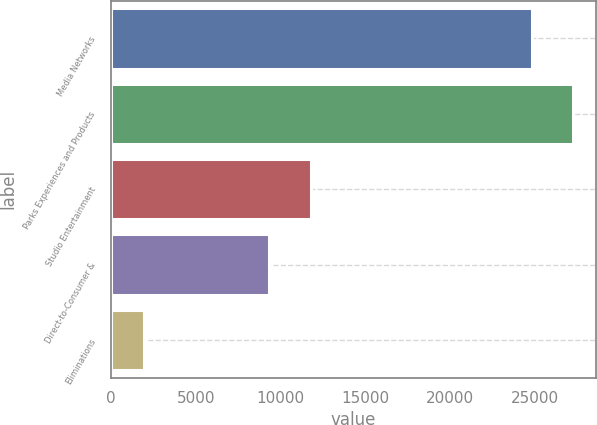<chart> <loc_0><loc_0><loc_500><loc_500><bar_chart><fcel>Media Networks<fcel>Parks Experiences and Products<fcel>Studio Entertainment<fcel>Direct-to-Consumer &<fcel>Eliminations<nl><fcel>24827<fcel>27253.7<fcel>11775.7<fcel>9349<fcel>1958<nl></chart> 